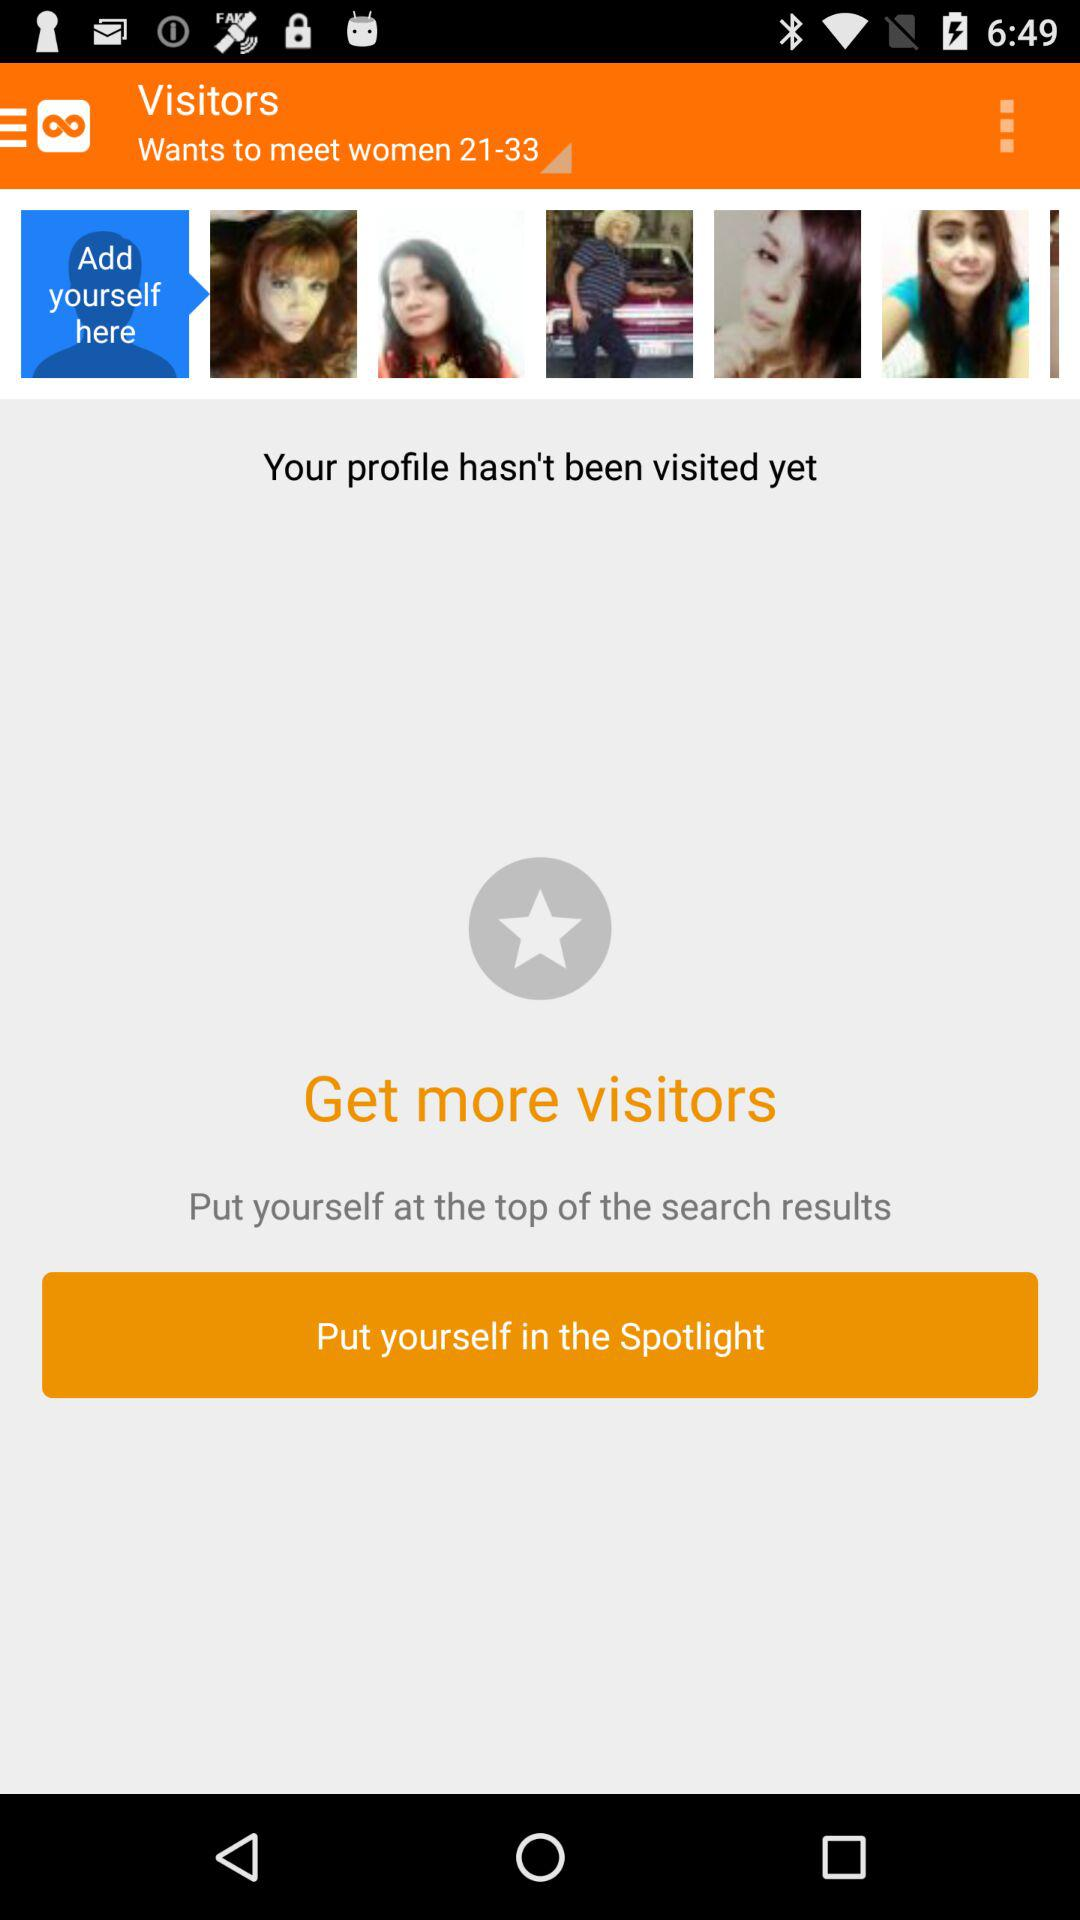What is the name of the application? The name of the application is "Twoo". 